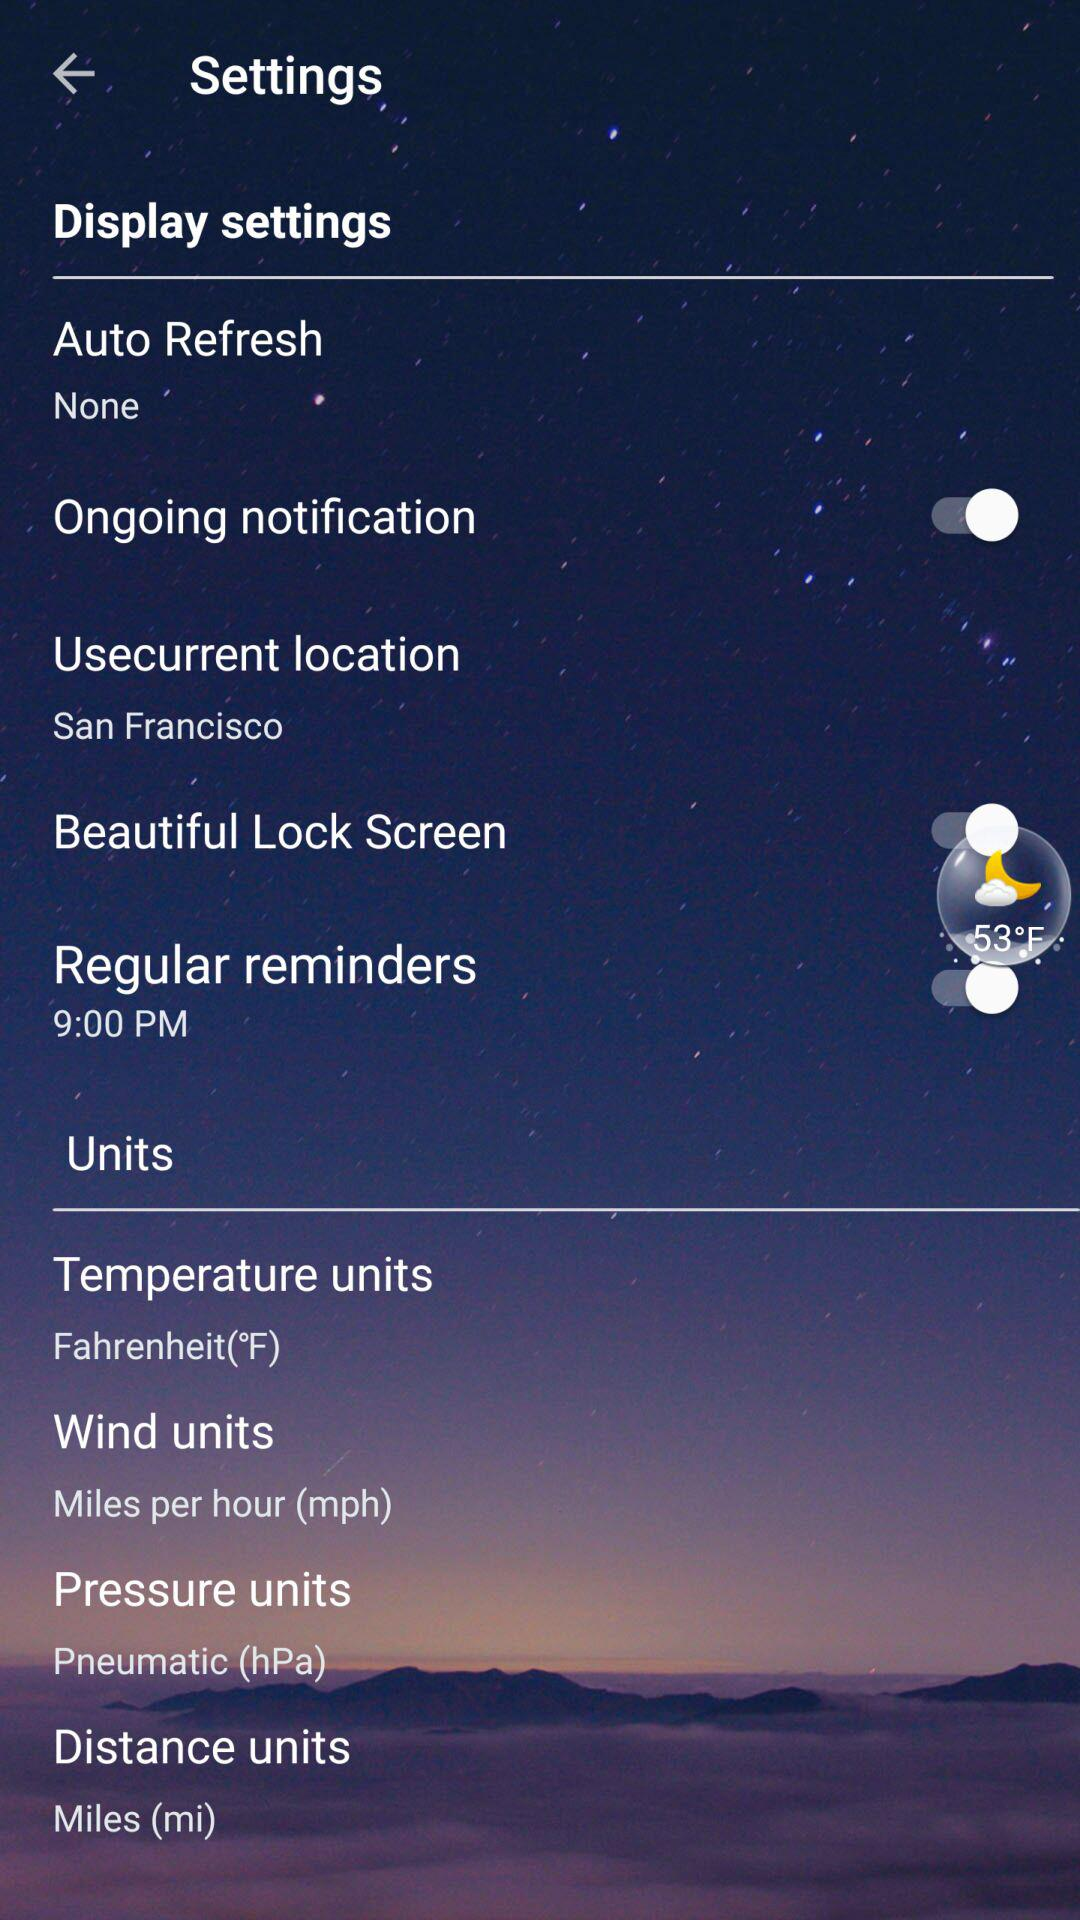How many items have a switch associated with them?
Answer the question using a single word or phrase. 3 